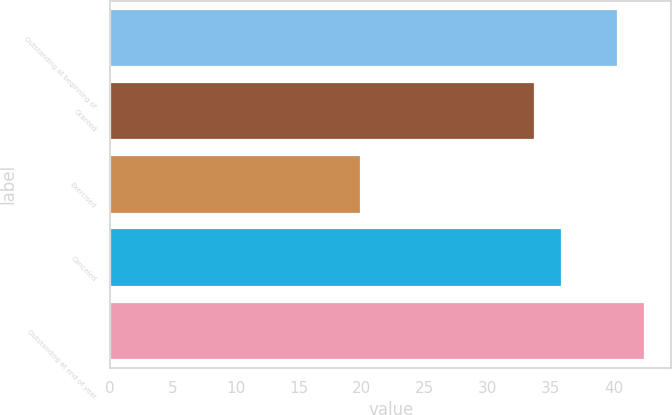<chart> <loc_0><loc_0><loc_500><loc_500><bar_chart><fcel>Outstanding at beginning of<fcel>Granted<fcel>Exercised<fcel>Canceled<fcel>Outstanding at end of year<nl><fcel>40.36<fcel>33.77<fcel>19.92<fcel>35.86<fcel>42.45<nl></chart> 